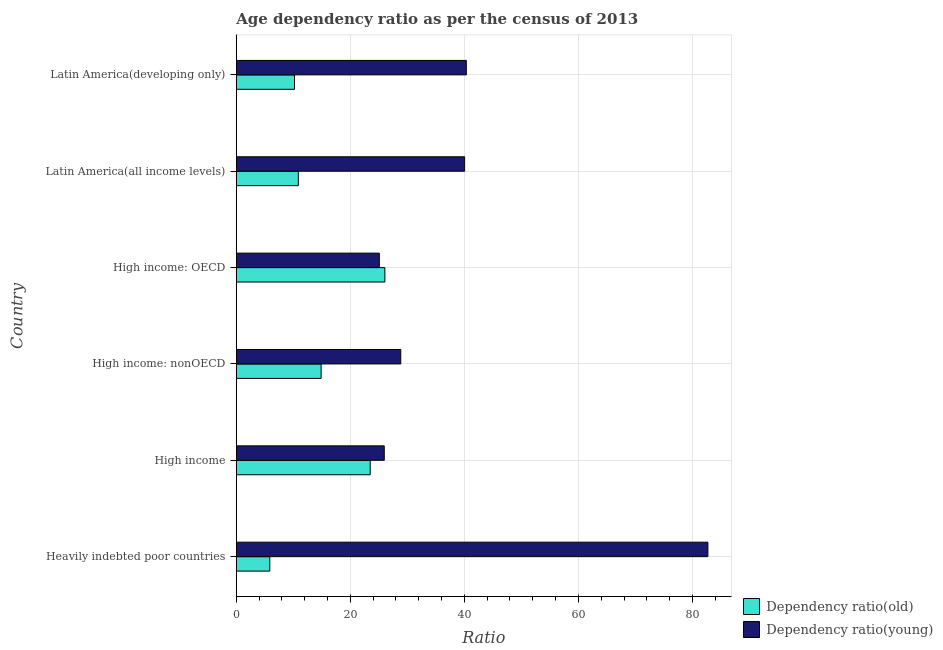How many groups of bars are there?
Provide a short and direct response. 6. Are the number of bars per tick equal to the number of legend labels?
Offer a terse response. Yes. What is the label of the 1st group of bars from the top?
Make the answer very short. Latin America(developing only). What is the age dependency ratio(old) in Latin America(developing only)?
Give a very brief answer. 10.22. Across all countries, what is the maximum age dependency ratio(old)?
Offer a very short reply. 26.06. Across all countries, what is the minimum age dependency ratio(old)?
Provide a short and direct response. 5.88. In which country was the age dependency ratio(old) maximum?
Your answer should be compact. High income: OECD. In which country was the age dependency ratio(old) minimum?
Ensure brevity in your answer.  Heavily indebted poor countries. What is the total age dependency ratio(young) in the graph?
Make the answer very short. 242.99. What is the difference between the age dependency ratio(old) in Latin America(all income levels) and that in Latin America(developing only)?
Your answer should be very brief. 0.67. What is the difference between the age dependency ratio(young) in High income: OECD and the age dependency ratio(old) in High income: nonOECD?
Provide a succinct answer. 10.21. What is the average age dependency ratio(young) per country?
Provide a succinct answer. 40.5. What is the difference between the age dependency ratio(old) and age dependency ratio(young) in High income?
Your response must be concise. -2.46. In how many countries, is the age dependency ratio(young) greater than 4 ?
Ensure brevity in your answer.  6. What is the ratio of the age dependency ratio(old) in High income: nonOECD to that in Latin America(developing only)?
Provide a succinct answer. 1.46. Is the age dependency ratio(old) in High income: nonOECD less than that in Latin America(all income levels)?
Make the answer very short. No. Is the difference between the age dependency ratio(old) in Heavily indebted poor countries and Latin America(developing only) greater than the difference between the age dependency ratio(young) in Heavily indebted poor countries and Latin America(developing only)?
Provide a short and direct response. No. What is the difference between the highest and the second highest age dependency ratio(old)?
Your response must be concise. 2.57. What is the difference between the highest and the lowest age dependency ratio(young)?
Your response must be concise. 57.62. Is the sum of the age dependency ratio(young) in High income: nonOECD and Latin America(developing only) greater than the maximum age dependency ratio(old) across all countries?
Your answer should be compact. Yes. What does the 1st bar from the top in High income: nonOECD represents?
Make the answer very short. Dependency ratio(young). What does the 2nd bar from the bottom in Latin America(developing only) represents?
Provide a succinct answer. Dependency ratio(young). How many bars are there?
Offer a terse response. 12. Are all the bars in the graph horizontal?
Offer a very short reply. Yes. What is the difference between two consecutive major ticks on the X-axis?
Provide a succinct answer. 20. Does the graph contain any zero values?
Provide a succinct answer. No. Where does the legend appear in the graph?
Give a very brief answer. Bottom right. What is the title of the graph?
Your answer should be very brief. Age dependency ratio as per the census of 2013. What is the label or title of the X-axis?
Make the answer very short. Ratio. What is the label or title of the Y-axis?
Give a very brief answer. Country. What is the Ratio in Dependency ratio(old) in Heavily indebted poor countries?
Ensure brevity in your answer.  5.88. What is the Ratio of Dependency ratio(young) in Heavily indebted poor countries?
Your response must be concise. 82.71. What is the Ratio in Dependency ratio(old) in High income?
Provide a short and direct response. 23.49. What is the Ratio in Dependency ratio(young) in High income?
Offer a very short reply. 25.95. What is the Ratio in Dependency ratio(old) in High income: nonOECD?
Provide a short and direct response. 14.88. What is the Ratio in Dependency ratio(young) in High income: nonOECD?
Your answer should be compact. 28.85. What is the Ratio of Dependency ratio(old) in High income: OECD?
Your answer should be very brief. 26.06. What is the Ratio in Dependency ratio(young) in High income: OECD?
Make the answer very short. 25.09. What is the Ratio in Dependency ratio(old) in Latin America(all income levels)?
Provide a short and direct response. 10.89. What is the Ratio of Dependency ratio(young) in Latin America(all income levels)?
Keep it short and to the point. 40.05. What is the Ratio of Dependency ratio(old) in Latin America(developing only)?
Your answer should be compact. 10.22. What is the Ratio of Dependency ratio(young) in Latin America(developing only)?
Your answer should be very brief. 40.34. Across all countries, what is the maximum Ratio in Dependency ratio(old)?
Offer a terse response. 26.06. Across all countries, what is the maximum Ratio of Dependency ratio(young)?
Keep it short and to the point. 82.71. Across all countries, what is the minimum Ratio in Dependency ratio(old)?
Offer a terse response. 5.88. Across all countries, what is the minimum Ratio of Dependency ratio(young)?
Offer a very short reply. 25.09. What is the total Ratio of Dependency ratio(old) in the graph?
Provide a short and direct response. 91.42. What is the total Ratio in Dependency ratio(young) in the graph?
Offer a very short reply. 242.99. What is the difference between the Ratio of Dependency ratio(old) in Heavily indebted poor countries and that in High income?
Give a very brief answer. -17.61. What is the difference between the Ratio in Dependency ratio(young) in Heavily indebted poor countries and that in High income?
Provide a succinct answer. 56.75. What is the difference between the Ratio in Dependency ratio(old) in Heavily indebted poor countries and that in High income: nonOECD?
Offer a terse response. -9.01. What is the difference between the Ratio of Dependency ratio(young) in Heavily indebted poor countries and that in High income: nonOECD?
Give a very brief answer. 53.86. What is the difference between the Ratio of Dependency ratio(old) in Heavily indebted poor countries and that in High income: OECD?
Provide a succinct answer. -20.18. What is the difference between the Ratio of Dependency ratio(young) in Heavily indebted poor countries and that in High income: OECD?
Give a very brief answer. 57.62. What is the difference between the Ratio of Dependency ratio(old) in Heavily indebted poor countries and that in Latin America(all income levels)?
Offer a very short reply. -5.01. What is the difference between the Ratio of Dependency ratio(young) in Heavily indebted poor countries and that in Latin America(all income levels)?
Give a very brief answer. 42.66. What is the difference between the Ratio of Dependency ratio(old) in Heavily indebted poor countries and that in Latin America(developing only)?
Give a very brief answer. -4.34. What is the difference between the Ratio of Dependency ratio(young) in Heavily indebted poor countries and that in Latin America(developing only)?
Ensure brevity in your answer.  42.36. What is the difference between the Ratio of Dependency ratio(old) in High income and that in High income: nonOECD?
Give a very brief answer. 8.61. What is the difference between the Ratio of Dependency ratio(young) in High income and that in High income: nonOECD?
Provide a succinct answer. -2.89. What is the difference between the Ratio of Dependency ratio(old) in High income and that in High income: OECD?
Your response must be concise. -2.57. What is the difference between the Ratio in Dependency ratio(young) in High income and that in High income: OECD?
Keep it short and to the point. 0.86. What is the difference between the Ratio of Dependency ratio(old) in High income and that in Latin America(all income levels)?
Offer a very short reply. 12.61. What is the difference between the Ratio of Dependency ratio(young) in High income and that in Latin America(all income levels)?
Keep it short and to the point. -14.09. What is the difference between the Ratio of Dependency ratio(old) in High income and that in Latin America(developing only)?
Give a very brief answer. 13.27. What is the difference between the Ratio of Dependency ratio(young) in High income and that in Latin America(developing only)?
Give a very brief answer. -14.39. What is the difference between the Ratio in Dependency ratio(old) in High income: nonOECD and that in High income: OECD?
Provide a succinct answer. -11.18. What is the difference between the Ratio of Dependency ratio(young) in High income: nonOECD and that in High income: OECD?
Keep it short and to the point. 3.76. What is the difference between the Ratio of Dependency ratio(old) in High income: nonOECD and that in Latin America(all income levels)?
Offer a terse response. 4. What is the difference between the Ratio of Dependency ratio(young) in High income: nonOECD and that in Latin America(all income levels)?
Offer a terse response. -11.2. What is the difference between the Ratio in Dependency ratio(old) in High income: nonOECD and that in Latin America(developing only)?
Ensure brevity in your answer.  4.67. What is the difference between the Ratio in Dependency ratio(young) in High income: nonOECD and that in Latin America(developing only)?
Make the answer very short. -11.49. What is the difference between the Ratio of Dependency ratio(old) in High income: OECD and that in Latin America(all income levels)?
Provide a short and direct response. 15.17. What is the difference between the Ratio of Dependency ratio(young) in High income: OECD and that in Latin America(all income levels)?
Keep it short and to the point. -14.96. What is the difference between the Ratio of Dependency ratio(old) in High income: OECD and that in Latin America(developing only)?
Your answer should be very brief. 15.84. What is the difference between the Ratio in Dependency ratio(young) in High income: OECD and that in Latin America(developing only)?
Make the answer very short. -15.25. What is the difference between the Ratio of Dependency ratio(old) in Latin America(all income levels) and that in Latin America(developing only)?
Give a very brief answer. 0.67. What is the difference between the Ratio in Dependency ratio(young) in Latin America(all income levels) and that in Latin America(developing only)?
Offer a terse response. -0.3. What is the difference between the Ratio of Dependency ratio(old) in Heavily indebted poor countries and the Ratio of Dependency ratio(young) in High income?
Make the answer very short. -20.08. What is the difference between the Ratio in Dependency ratio(old) in Heavily indebted poor countries and the Ratio in Dependency ratio(young) in High income: nonOECD?
Make the answer very short. -22.97. What is the difference between the Ratio in Dependency ratio(old) in Heavily indebted poor countries and the Ratio in Dependency ratio(young) in High income: OECD?
Your response must be concise. -19.21. What is the difference between the Ratio in Dependency ratio(old) in Heavily indebted poor countries and the Ratio in Dependency ratio(young) in Latin America(all income levels)?
Offer a very short reply. -34.17. What is the difference between the Ratio of Dependency ratio(old) in Heavily indebted poor countries and the Ratio of Dependency ratio(young) in Latin America(developing only)?
Your response must be concise. -34.46. What is the difference between the Ratio of Dependency ratio(old) in High income and the Ratio of Dependency ratio(young) in High income: nonOECD?
Keep it short and to the point. -5.36. What is the difference between the Ratio in Dependency ratio(old) in High income and the Ratio in Dependency ratio(young) in High income: OECD?
Give a very brief answer. -1.6. What is the difference between the Ratio in Dependency ratio(old) in High income and the Ratio in Dependency ratio(young) in Latin America(all income levels)?
Offer a terse response. -16.56. What is the difference between the Ratio in Dependency ratio(old) in High income and the Ratio in Dependency ratio(young) in Latin America(developing only)?
Provide a short and direct response. -16.85. What is the difference between the Ratio in Dependency ratio(old) in High income: nonOECD and the Ratio in Dependency ratio(young) in High income: OECD?
Keep it short and to the point. -10.21. What is the difference between the Ratio in Dependency ratio(old) in High income: nonOECD and the Ratio in Dependency ratio(young) in Latin America(all income levels)?
Your response must be concise. -25.16. What is the difference between the Ratio in Dependency ratio(old) in High income: nonOECD and the Ratio in Dependency ratio(young) in Latin America(developing only)?
Make the answer very short. -25.46. What is the difference between the Ratio of Dependency ratio(old) in High income: OECD and the Ratio of Dependency ratio(young) in Latin America(all income levels)?
Make the answer very short. -13.99. What is the difference between the Ratio of Dependency ratio(old) in High income: OECD and the Ratio of Dependency ratio(young) in Latin America(developing only)?
Your answer should be compact. -14.28. What is the difference between the Ratio of Dependency ratio(old) in Latin America(all income levels) and the Ratio of Dependency ratio(young) in Latin America(developing only)?
Provide a succinct answer. -29.46. What is the average Ratio of Dependency ratio(old) per country?
Your answer should be compact. 15.24. What is the average Ratio in Dependency ratio(young) per country?
Offer a terse response. 40.5. What is the difference between the Ratio of Dependency ratio(old) and Ratio of Dependency ratio(young) in Heavily indebted poor countries?
Your response must be concise. -76.83. What is the difference between the Ratio in Dependency ratio(old) and Ratio in Dependency ratio(young) in High income?
Make the answer very short. -2.46. What is the difference between the Ratio in Dependency ratio(old) and Ratio in Dependency ratio(young) in High income: nonOECD?
Provide a short and direct response. -13.96. What is the difference between the Ratio in Dependency ratio(old) and Ratio in Dependency ratio(young) in High income: OECD?
Give a very brief answer. 0.97. What is the difference between the Ratio of Dependency ratio(old) and Ratio of Dependency ratio(young) in Latin America(all income levels)?
Your answer should be compact. -29.16. What is the difference between the Ratio of Dependency ratio(old) and Ratio of Dependency ratio(young) in Latin America(developing only)?
Provide a succinct answer. -30.12. What is the ratio of the Ratio in Dependency ratio(old) in Heavily indebted poor countries to that in High income?
Provide a short and direct response. 0.25. What is the ratio of the Ratio in Dependency ratio(young) in Heavily indebted poor countries to that in High income?
Your response must be concise. 3.19. What is the ratio of the Ratio in Dependency ratio(old) in Heavily indebted poor countries to that in High income: nonOECD?
Provide a short and direct response. 0.39. What is the ratio of the Ratio in Dependency ratio(young) in Heavily indebted poor countries to that in High income: nonOECD?
Your answer should be very brief. 2.87. What is the ratio of the Ratio of Dependency ratio(old) in Heavily indebted poor countries to that in High income: OECD?
Provide a succinct answer. 0.23. What is the ratio of the Ratio in Dependency ratio(young) in Heavily indebted poor countries to that in High income: OECD?
Give a very brief answer. 3.3. What is the ratio of the Ratio in Dependency ratio(old) in Heavily indebted poor countries to that in Latin America(all income levels)?
Give a very brief answer. 0.54. What is the ratio of the Ratio of Dependency ratio(young) in Heavily indebted poor countries to that in Latin America(all income levels)?
Your response must be concise. 2.07. What is the ratio of the Ratio of Dependency ratio(old) in Heavily indebted poor countries to that in Latin America(developing only)?
Keep it short and to the point. 0.58. What is the ratio of the Ratio of Dependency ratio(young) in Heavily indebted poor countries to that in Latin America(developing only)?
Make the answer very short. 2.05. What is the ratio of the Ratio of Dependency ratio(old) in High income to that in High income: nonOECD?
Offer a terse response. 1.58. What is the ratio of the Ratio of Dependency ratio(young) in High income to that in High income: nonOECD?
Make the answer very short. 0.9. What is the ratio of the Ratio in Dependency ratio(old) in High income to that in High income: OECD?
Keep it short and to the point. 0.9. What is the ratio of the Ratio of Dependency ratio(young) in High income to that in High income: OECD?
Make the answer very short. 1.03. What is the ratio of the Ratio of Dependency ratio(old) in High income to that in Latin America(all income levels)?
Your response must be concise. 2.16. What is the ratio of the Ratio in Dependency ratio(young) in High income to that in Latin America(all income levels)?
Your answer should be compact. 0.65. What is the ratio of the Ratio in Dependency ratio(old) in High income to that in Latin America(developing only)?
Give a very brief answer. 2.3. What is the ratio of the Ratio in Dependency ratio(young) in High income to that in Latin America(developing only)?
Your answer should be compact. 0.64. What is the ratio of the Ratio in Dependency ratio(old) in High income: nonOECD to that in High income: OECD?
Offer a very short reply. 0.57. What is the ratio of the Ratio in Dependency ratio(young) in High income: nonOECD to that in High income: OECD?
Offer a very short reply. 1.15. What is the ratio of the Ratio in Dependency ratio(old) in High income: nonOECD to that in Latin America(all income levels)?
Your answer should be compact. 1.37. What is the ratio of the Ratio of Dependency ratio(young) in High income: nonOECD to that in Latin America(all income levels)?
Provide a succinct answer. 0.72. What is the ratio of the Ratio in Dependency ratio(old) in High income: nonOECD to that in Latin America(developing only)?
Your answer should be very brief. 1.46. What is the ratio of the Ratio in Dependency ratio(young) in High income: nonOECD to that in Latin America(developing only)?
Your response must be concise. 0.72. What is the ratio of the Ratio of Dependency ratio(old) in High income: OECD to that in Latin America(all income levels)?
Provide a short and direct response. 2.39. What is the ratio of the Ratio in Dependency ratio(young) in High income: OECD to that in Latin America(all income levels)?
Your answer should be very brief. 0.63. What is the ratio of the Ratio in Dependency ratio(old) in High income: OECD to that in Latin America(developing only)?
Your answer should be compact. 2.55. What is the ratio of the Ratio of Dependency ratio(young) in High income: OECD to that in Latin America(developing only)?
Keep it short and to the point. 0.62. What is the ratio of the Ratio of Dependency ratio(old) in Latin America(all income levels) to that in Latin America(developing only)?
Make the answer very short. 1.07. What is the ratio of the Ratio of Dependency ratio(young) in Latin America(all income levels) to that in Latin America(developing only)?
Your answer should be very brief. 0.99. What is the difference between the highest and the second highest Ratio in Dependency ratio(old)?
Make the answer very short. 2.57. What is the difference between the highest and the second highest Ratio of Dependency ratio(young)?
Keep it short and to the point. 42.36. What is the difference between the highest and the lowest Ratio in Dependency ratio(old)?
Give a very brief answer. 20.18. What is the difference between the highest and the lowest Ratio in Dependency ratio(young)?
Keep it short and to the point. 57.62. 